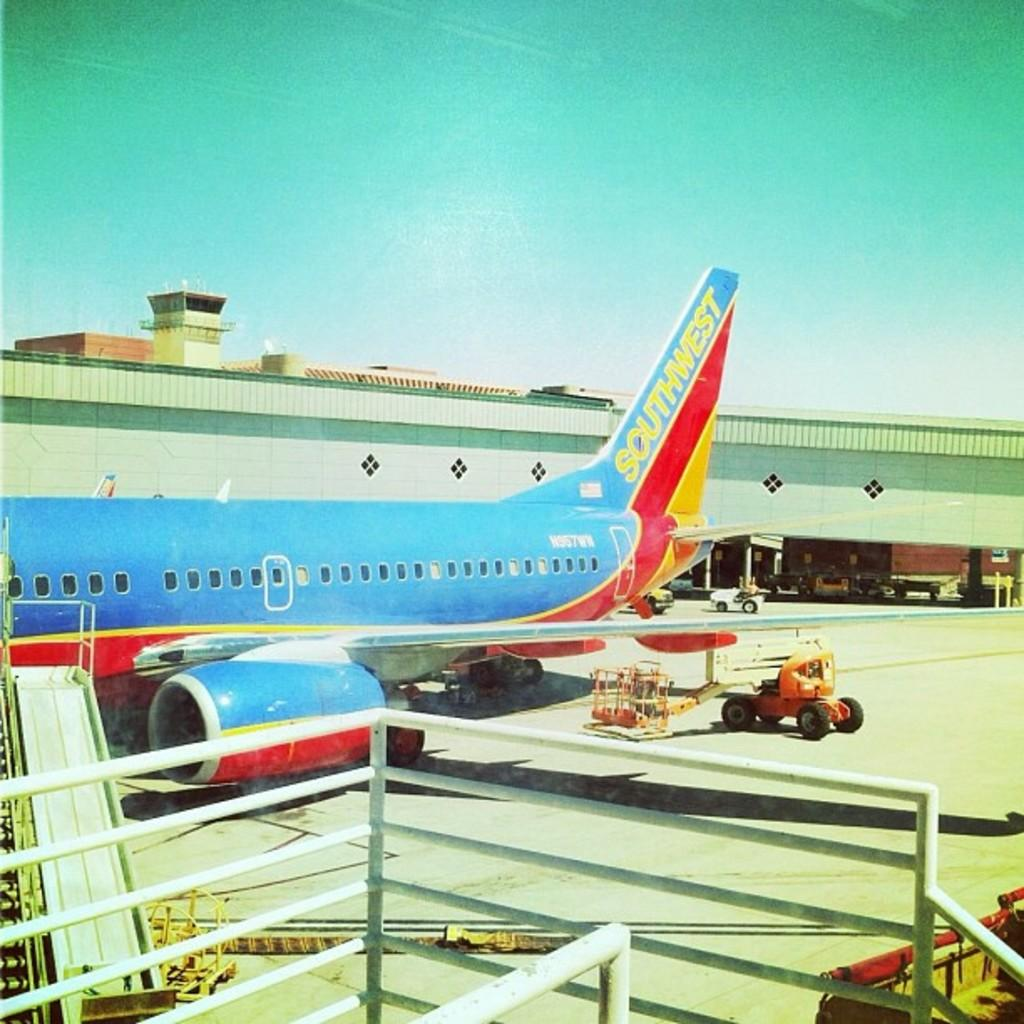What is the main subject of the image? The main subject of the image is an airplane. What is the airplane's current state in the image? The airplane is standing on the ground. What other vehicles can be seen in the image? There are other vehicles on the ground. Can you describe any additional features in the image? There are stairs in the image. What can be seen in the background of the image? There is a building visible in the background. How does the airplane twist in the image? The airplane does not twist in the image; it is standing on the ground with its wings parallel to the ground. 